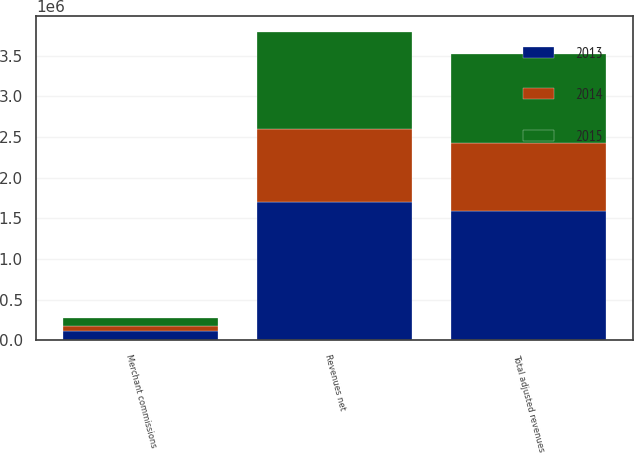Convert chart to OTSL. <chart><loc_0><loc_0><loc_500><loc_500><stacked_bar_chart><ecel><fcel>Revenues net<fcel>Merchant commissions<fcel>Total adjusted revenues<nl><fcel>2013<fcel>1.70286e+06<fcel>108257<fcel>1.59461e+06<nl><fcel>2015<fcel>1.19939e+06<fcel>96254<fcel>1.10314e+06<nl><fcel>2014<fcel>895171<fcel>68143<fcel>827028<nl></chart> 